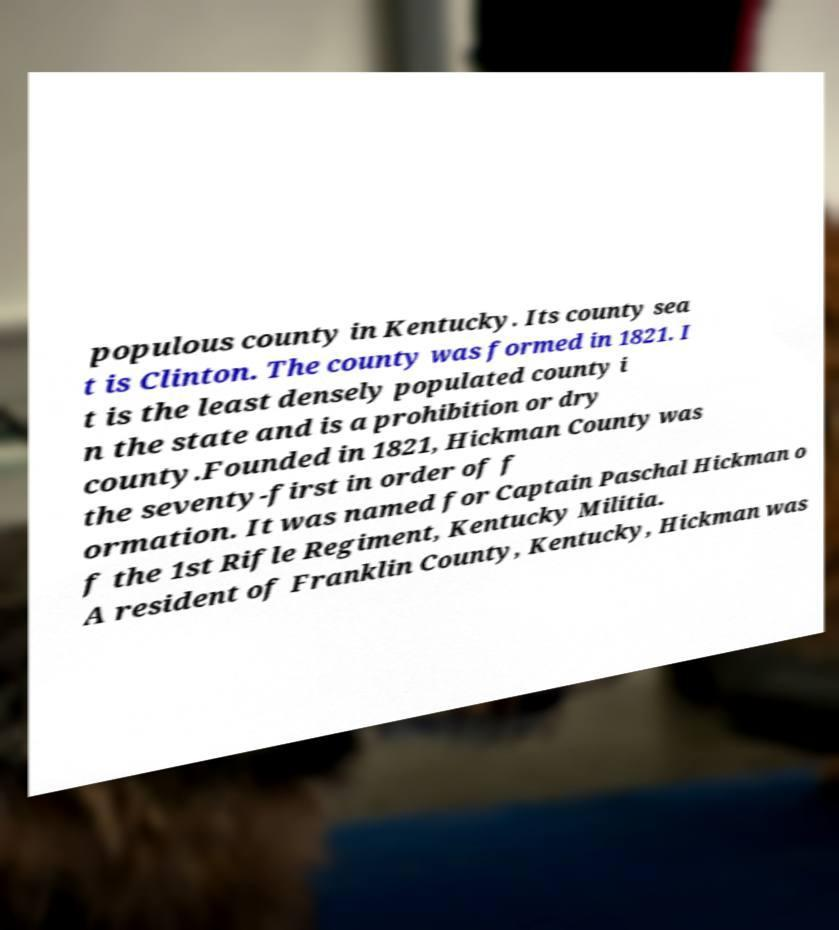For documentation purposes, I need the text within this image transcribed. Could you provide that? populous county in Kentucky. Its county sea t is Clinton. The county was formed in 1821. I t is the least densely populated county i n the state and is a prohibition or dry county.Founded in 1821, Hickman County was the seventy-first in order of f ormation. It was named for Captain Paschal Hickman o f the 1st Rifle Regiment, Kentucky Militia. A resident of Franklin County, Kentucky, Hickman was 